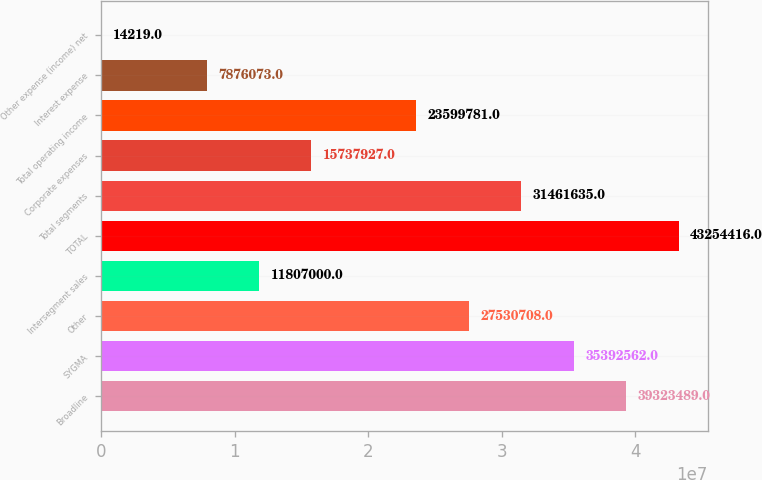Convert chart to OTSL. <chart><loc_0><loc_0><loc_500><loc_500><bar_chart><fcel>Broadline<fcel>SYGMA<fcel>Other<fcel>Intersegment sales<fcel>TOTAL<fcel>Total segments<fcel>Corporate expenses<fcel>Total operating income<fcel>Interest expense<fcel>Other expense (income) net<nl><fcel>3.93235e+07<fcel>3.53926e+07<fcel>2.75307e+07<fcel>1.1807e+07<fcel>4.32544e+07<fcel>3.14616e+07<fcel>1.57379e+07<fcel>2.35998e+07<fcel>7.87607e+06<fcel>14219<nl></chart> 